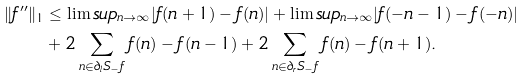<formula> <loc_0><loc_0><loc_500><loc_500>\| f ^ { \prime \prime } \| _ { 1 } & \leq \lim s u p _ { n \rightarrow \infty } | f ( n + 1 ) - f ( n ) | + \lim s u p _ { n \rightarrow \infty } | f ( - n - 1 ) - f ( - n ) | \\ & + 2 \sum _ { n \in \partial _ { l } S _ { - } f } f ( n ) - f ( n - 1 ) + 2 \sum _ { n \in \partial _ { r } S _ { - } f } f ( n ) - f ( n + 1 ) .</formula> 